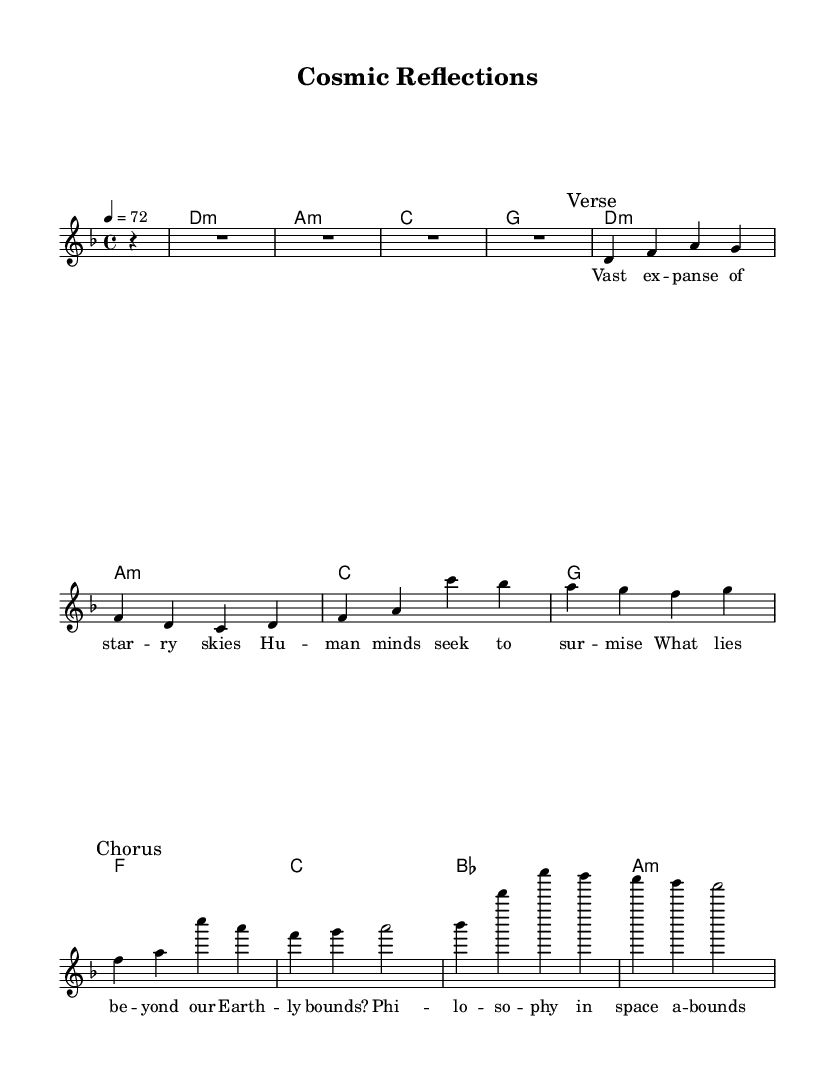What is the key signature of this music? The key signature is indicated at the beginning of the score. In this case, it shows two flats, indicating that the piece is in D minor.
Answer: D minor What is the time signature of this music? The time signature is specified at the beginning of the score, which shows a "4/4" indicating four beats per measure.
Answer: 4/4 What is the tempo marking for this piece? The tempo marking is located in the header section of the score where it notes "4 = 72," meaning a quarter note is equal to 72 beats per minute.
Answer: 72 How many measures are there in the verse? To find the number of measures in the verse, I can count the sections marked "Verse" in the score. The verse has four measures.
Answer: 4 What are the primary chords in the chorus? The primary chords can be found under the "Chorus" section in the chord mode; they are F, A minor, and B flat. These chords give the chorus its harmonic structure.
Answer: F, A minor, B flat In which section of the song do the lyrics begin with "Vast expanse of starry skies"? Looking at the lyrics provided, they start under the section marked "Verse," indicating that this is part of the verse lyrics.
Answer: Verse What philosophical themes are reflected in the lyrics? The lyrics present thoughts on the vastness of space and the search for meaning beyond earthly existence, suggesting a focus on exploration and existential inquiry.
Answer: Exploration and existential inquiry 